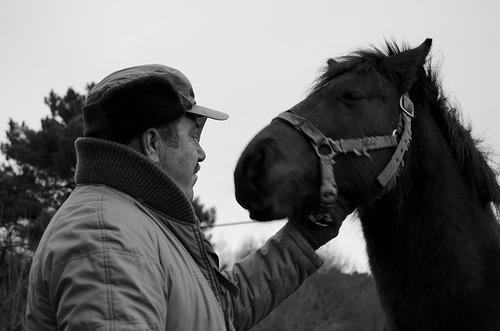How many animals appear in this photo?
Give a very brief answer. 1. How many people are seen in this picture?
Give a very brief answer. 1. 